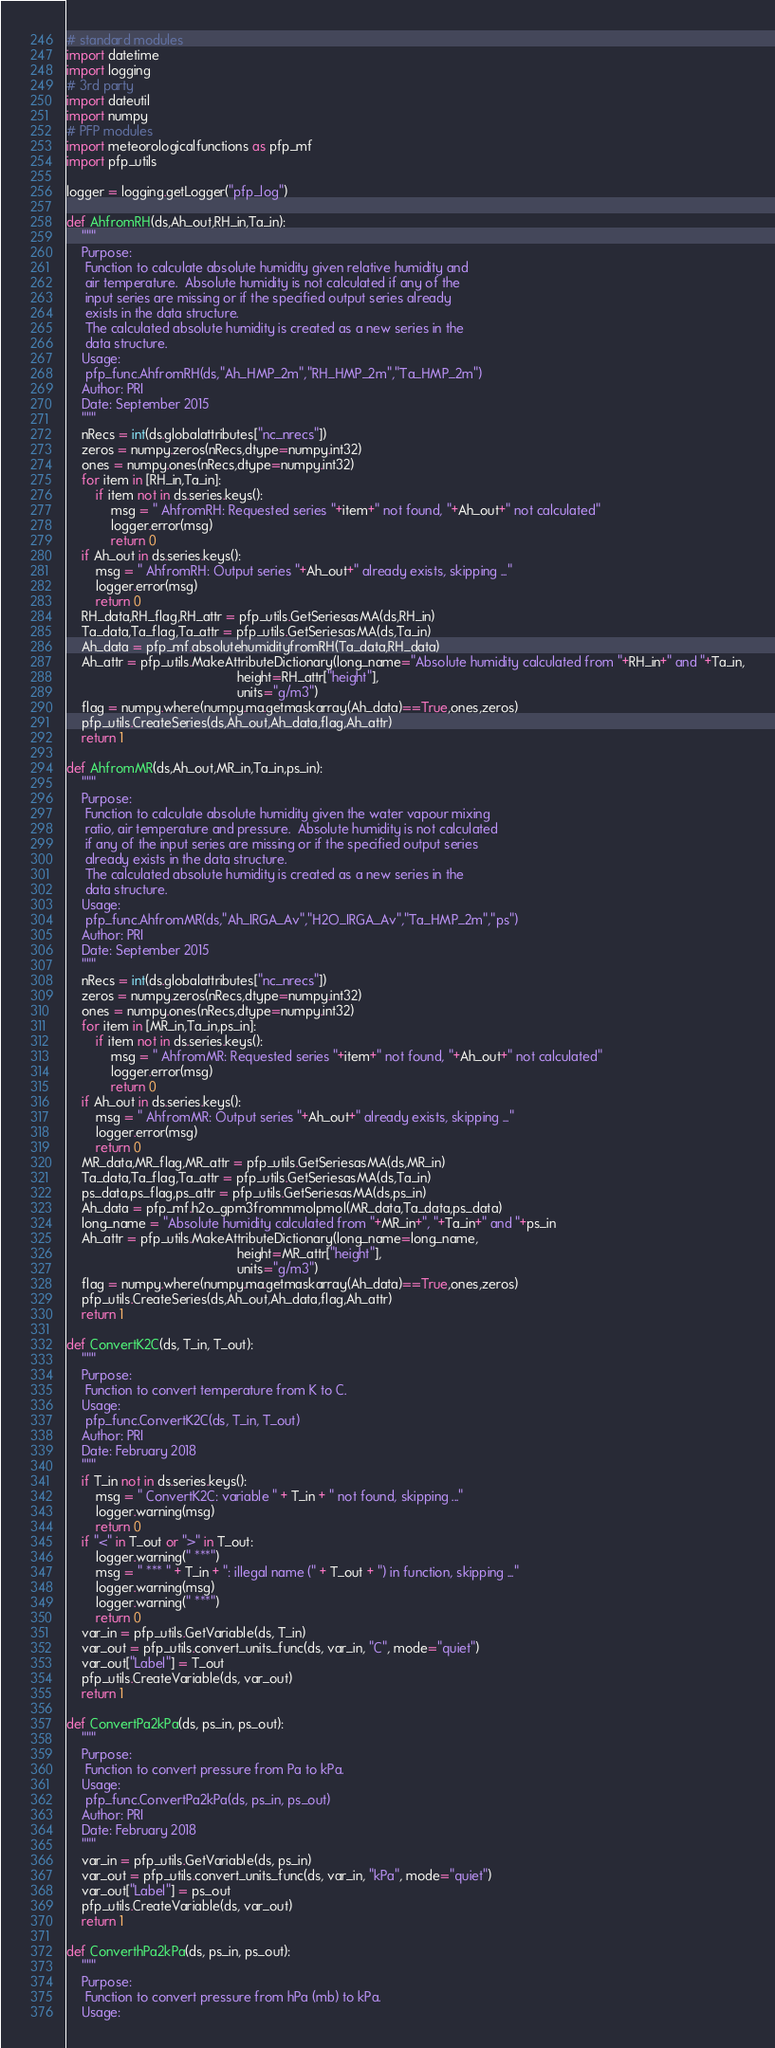<code> <loc_0><loc_0><loc_500><loc_500><_Python_># standard modules
import datetime
import logging
# 3rd party
import dateutil
import numpy
# PFP modules
import meteorologicalfunctions as pfp_mf
import pfp_utils

logger = logging.getLogger("pfp_log")

def AhfromRH(ds,Ah_out,RH_in,Ta_in):
    """
    Purpose:
     Function to calculate absolute humidity given relative humidity and
     air temperature.  Absolute humidity is not calculated if any of the
     input series are missing or if the specified output series already
     exists in the data structure.
     The calculated absolute humidity is created as a new series in the
     data structure.
    Usage:
     pfp_func.AhfromRH(ds,"Ah_HMP_2m","RH_HMP_2m","Ta_HMP_2m")
    Author: PRI
    Date: September 2015
    """
    nRecs = int(ds.globalattributes["nc_nrecs"])
    zeros = numpy.zeros(nRecs,dtype=numpy.int32)
    ones = numpy.ones(nRecs,dtype=numpy.int32)
    for item in [RH_in,Ta_in]:
        if item not in ds.series.keys():
            msg = " AhfromRH: Requested series "+item+" not found, "+Ah_out+" not calculated"
            logger.error(msg)
            return 0
    if Ah_out in ds.series.keys():
        msg = " AhfromRH: Output series "+Ah_out+" already exists, skipping ..."
        logger.error(msg)
        return 0
    RH_data,RH_flag,RH_attr = pfp_utils.GetSeriesasMA(ds,RH_in)
    Ta_data,Ta_flag,Ta_attr = pfp_utils.GetSeriesasMA(ds,Ta_in)
    Ah_data = pfp_mf.absolutehumidityfromRH(Ta_data,RH_data)
    Ah_attr = pfp_utils.MakeAttributeDictionary(long_name="Absolute humidity calculated from "+RH_in+" and "+Ta_in,
                                              height=RH_attr["height"],
                                              units="g/m3")
    flag = numpy.where(numpy.ma.getmaskarray(Ah_data)==True,ones,zeros)
    pfp_utils.CreateSeries(ds,Ah_out,Ah_data,flag,Ah_attr)
    return 1

def AhfromMR(ds,Ah_out,MR_in,Ta_in,ps_in):
    """
    Purpose:
     Function to calculate absolute humidity given the water vapour mixing
     ratio, air temperature and pressure.  Absolute humidity is not calculated
     if any of the input series are missing or if the specified output series
     already exists in the data structure.
     The calculated absolute humidity is created as a new series in the
     data structure.
    Usage:
     pfp_func.AhfromMR(ds,"Ah_IRGA_Av","H2O_IRGA_Av","Ta_HMP_2m","ps")
    Author: PRI
    Date: September 2015
    """
    nRecs = int(ds.globalattributes["nc_nrecs"])
    zeros = numpy.zeros(nRecs,dtype=numpy.int32)
    ones = numpy.ones(nRecs,dtype=numpy.int32)
    for item in [MR_in,Ta_in,ps_in]:
        if item not in ds.series.keys():
            msg = " AhfromMR: Requested series "+item+" not found, "+Ah_out+" not calculated"
            logger.error(msg)
            return 0
    if Ah_out in ds.series.keys():
        msg = " AhfromMR: Output series "+Ah_out+" already exists, skipping ..."
        logger.error(msg)
        return 0
    MR_data,MR_flag,MR_attr = pfp_utils.GetSeriesasMA(ds,MR_in)
    Ta_data,Ta_flag,Ta_attr = pfp_utils.GetSeriesasMA(ds,Ta_in)
    ps_data,ps_flag,ps_attr = pfp_utils.GetSeriesasMA(ds,ps_in)
    Ah_data = pfp_mf.h2o_gpm3frommmolpmol(MR_data,Ta_data,ps_data)
    long_name = "Absolute humidity calculated from "+MR_in+", "+Ta_in+" and "+ps_in
    Ah_attr = pfp_utils.MakeAttributeDictionary(long_name=long_name,
                                              height=MR_attr["height"],
                                              units="g/m3")
    flag = numpy.where(numpy.ma.getmaskarray(Ah_data)==True,ones,zeros)
    pfp_utils.CreateSeries(ds,Ah_out,Ah_data,flag,Ah_attr)
    return 1

def ConvertK2C(ds, T_in, T_out):
    """
    Purpose:
     Function to convert temperature from K to C.
    Usage:
     pfp_func.ConvertK2C(ds, T_in, T_out)
    Author: PRI
    Date: February 2018
    """
    if T_in not in ds.series.keys():
        msg = " ConvertK2C: variable " + T_in + " not found, skipping ..."
        logger.warning(msg)
        return 0
    if "<" in T_out or ">" in T_out:
        logger.warning(" ***")
        msg = " *** " + T_in + ": illegal name (" + T_out + ") in function, skipping ..."
        logger.warning(msg)
        logger.warning(" ***")
        return 0
    var_in = pfp_utils.GetVariable(ds, T_in)
    var_out = pfp_utils.convert_units_func(ds, var_in, "C", mode="quiet")
    var_out["Label"] = T_out
    pfp_utils.CreateVariable(ds, var_out)
    return 1

def ConvertPa2kPa(ds, ps_in, ps_out):
    """
    Purpose:
     Function to convert pressure from Pa to kPa.
    Usage:
     pfp_func.ConvertPa2kPa(ds, ps_in, ps_out)
    Author: PRI
    Date: February 2018
    """
    var_in = pfp_utils.GetVariable(ds, ps_in)
    var_out = pfp_utils.convert_units_func(ds, var_in, "kPa", mode="quiet")
    var_out["Label"] = ps_out
    pfp_utils.CreateVariable(ds, var_out)
    return 1

def ConverthPa2kPa(ds, ps_in, ps_out):
    """
    Purpose:
     Function to convert pressure from hPa (mb) to kPa.
    Usage:</code> 